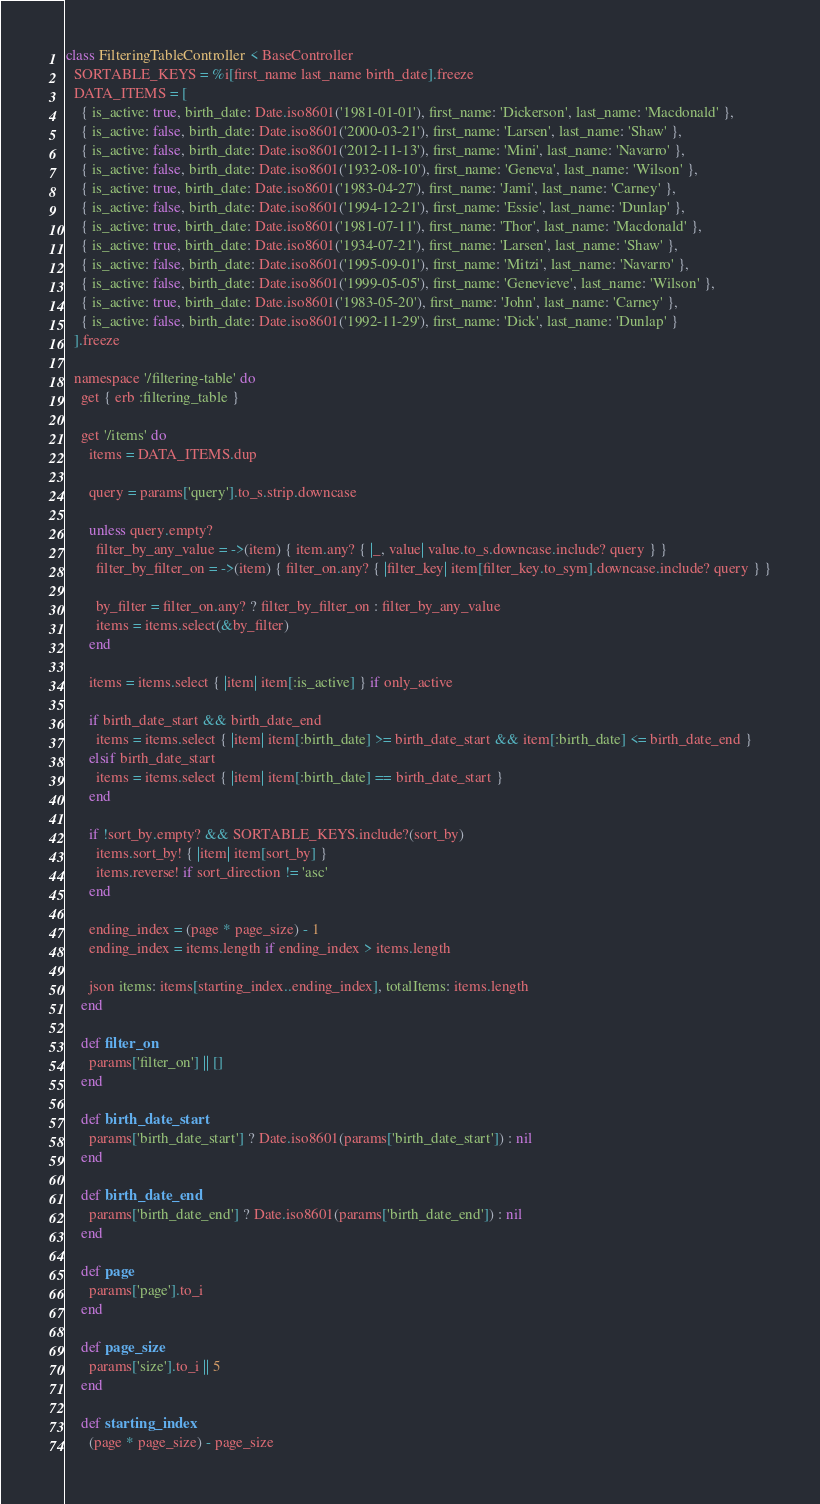<code> <loc_0><loc_0><loc_500><loc_500><_Ruby_>class FilteringTableController < BaseController
  SORTABLE_KEYS = %i[first_name last_name birth_date].freeze
  DATA_ITEMS = [
    { is_active: true, birth_date: Date.iso8601('1981-01-01'), first_name: 'Dickerson', last_name: 'Macdonald' },
    { is_active: false, birth_date: Date.iso8601('2000-03-21'), first_name: 'Larsen', last_name: 'Shaw' },
    { is_active: false, birth_date: Date.iso8601('2012-11-13'), first_name: 'Mini', last_name: 'Navarro' },
    { is_active: false, birth_date: Date.iso8601('1932-08-10'), first_name: 'Geneva', last_name: 'Wilson' },
    { is_active: true, birth_date: Date.iso8601('1983-04-27'), first_name: 'Jami', last_name: 'Carney' },
    { is_active: false, birth_date: Date.iso8601('1994-12-21'), first_name: 'Essie', last_name: 'Dunlap' },
    { is_active: true, birth_date: Date.iso8601('1981-07-11'), first_name: 'Thor', last_name: 'Macdonald' },
    { is_active: true, birth_date: Date.iso8601('1934-07-21'), first_name: 'Larsen', last_name: 'Shaw' },
    { is_active: false, birth_date: Date.iso8601('1995-09-01'), first_name: 'Mitzi', last_name: 'Navarro' },
    { is_active: false, birth_date: Date.iso8601('1999-05-05'), first_name: 'Genevieve', last_name: 'Wilson' },
    { is_active: true, birth_date: Date.iso8601('1983-05-20'), first_name: 'John', last_name: 'Carney' },
    { is_active: false, birth_date: Date.iso8601('1992-11-29'), first_name: 'Dick', last_name: 'Dunlap' }
  ].freeze

  namespace '/filtering-table' do
    get { erb :filtering_table }

    get '/items' do
      items = DATA_ITEMS.dup

      query = params['query'].to_s.strip.downcase

      unless query.empty?
        filter_by_any_value = ->(item) { item.any? { |_, value| value.to_s.downcase.include? query } }
        filter_by_filter_on = ->(item) { filter_on.any? { |filter_key| item[filter_key.to_sym].downcase.include? query } }

        by_filter = filter_on.any? ? filter_by_filter_on : filter_by_any_value
        items = items.select(&by_filter)
      end

      items = items.select { |item| item[:is_active] } if only_active

      if birth_date_start && birth_date_end
        items = items.select { |item| item[:birth_date] >= birth_date_start && item[:birth_date] <= birth_date_end }
      elsif birth_date_start
        items = items.select { |item| item[:birth_date] == birth_date_start }
      end

      if !sort_by.empty? && SORTABLE_KEYS.include?(sort_by)
        items.sort_by! { |item| item[sort_by] }
        items.reverse! if sort_direction != 'asc'
      end

      ending_index = (page * page_size) - 1
      ending_index = items.length if ending_index > items.length

      json items: items[starting_index..ending_index], totalItems: items.length
    end

    def filter_on
      params['filter_on'] || []
    end

    def birth_date_start
      params['birth_date_start'] ? Date.iso8601(params['birth_date_start']) : nil
    end

    def birth_date_end
      params['birth_date_end'] ? Date.iso8601(params['birth_date_end']) : nil
    end

    def page
      params['page'].to_i
    end

    def page_size
      params['size'].to_i || 5
    end

    def starting_index
      (page * page_size) - page_size</code> 